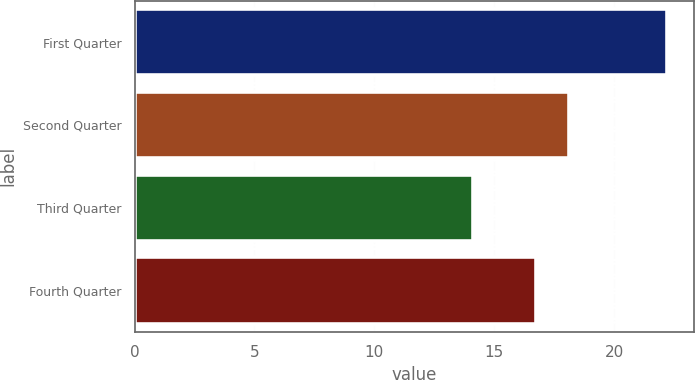<chart> <loc_0><loc_0><loc_500><loc_500><bar_chart><fcel>First Quarter<fcel>Second Quarter<fcel>Third Quarter<fcel>Fourth Quarter<nl><fcel>22.2<fcel>18.1<fcel>14.11<fcel>16.74<nl></chart> 